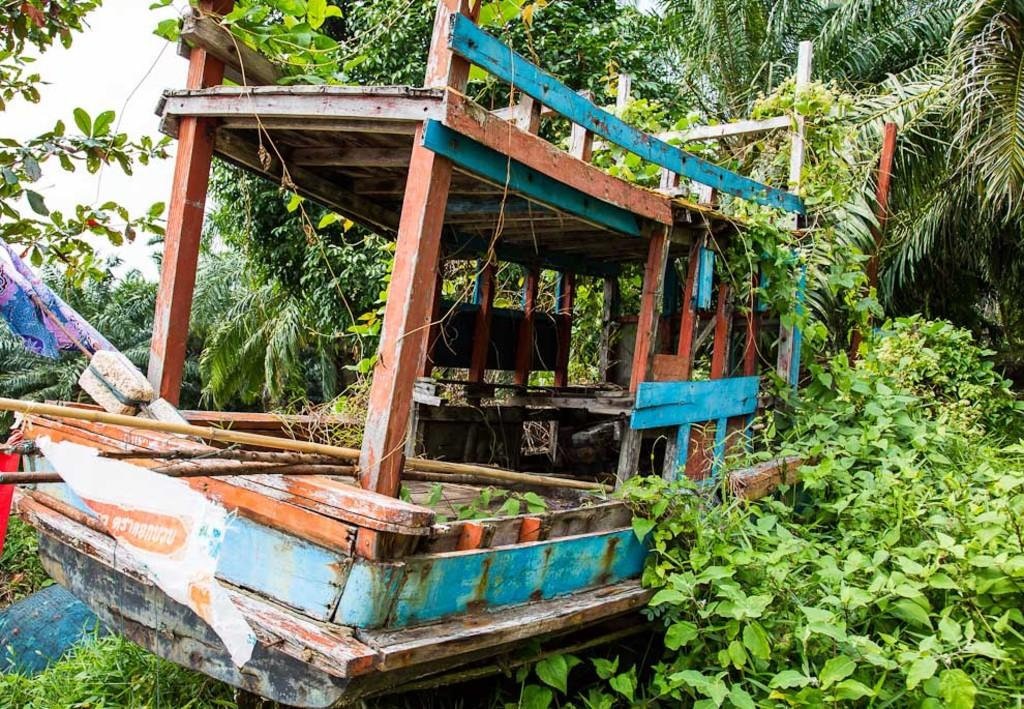What is the primary feature of the landscape in the image? There are many trees in the image. What is located in the middle of the image? There is a boat in the middle of the image. What material are the poles of the boat made of? The boat has wooden poles. What can be found in or around the boat? Stones are present in or around the boat, along with other unspecified things. What type of soup is being served on the tray in the image? There is no tray or soup present in the image. 